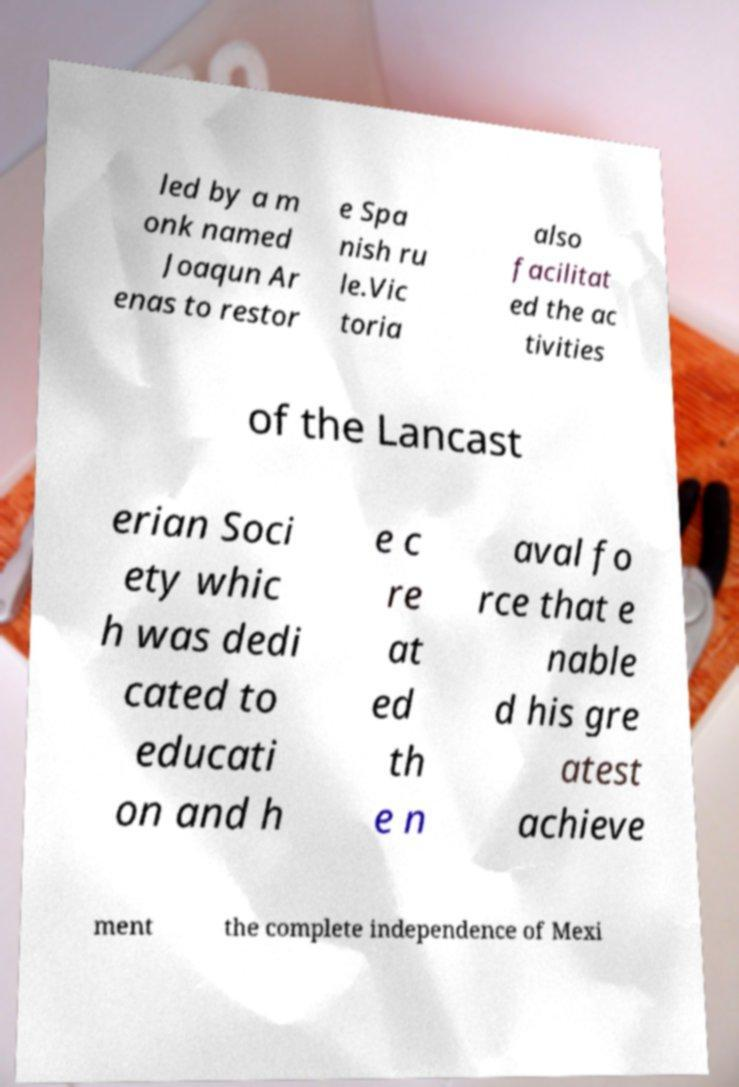Could you extract and type out the text from this image? led by a m onk named Joaqun Ar enas to restor e Spa nish ru le.Vic toria also facilitat ed the ac tivities of the Lancast erian Soci ety whic h was dedi cated to educati on and h e c re at ed th e n aval fo rce that e nable d his gre atest achieve ment the complete independence of Mexi 